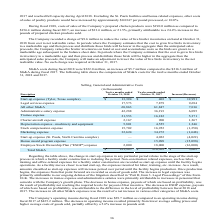From Sanderson Farms's financial document, What is the legal service expenses for fiscal years 2018 and 2017 respectively? The document shows two values: 17,573 and 7,879 (in thousands). From the document: "Legal services expense 17,573 7,879 9,694 Legal services expense 17,573 7,879 9,694..." Also, What is the Administrative salary expense for fiscal years 2018 and 2017 respectively? The document shows two values: 42,288 and 36,193 (in thousands). From the document: "Administrative salary expense 42,288 36,193 6,095 Administrative salary expense 42,288 36,193 6,095..." Also, What does the table show? the components of SG&A costs for the twelve months ended October 31, 2018 and 2017. The document states: "G&A during fiscal 2017. The following table shows the components of SG&A costs for the twelve months ended October 31, 2018 and 2017...." Also, can you calculate: What is the average Charter aircraft expense for fiscal years 2018 and 2017? To answer this question, I need to perform calculations using the financial data. The calculation is: (2,167+ 900)/2, which equals 1533.5 (in thousands). This is based on the information: "Charter aircraft expense 2,167 900 1,267 Charter aircraft expense 2,167 900 1,267..." The key data points involved are: 2,167, 900. Also, can you calculate: What is the average Employee Stock Ownership Plan ("ESOP") expense for fiscal years 2018 and 2017? To answer this question, I need to perform calculations using the financial data. The calculation is: (2,000+18,000)/2, which equals 10000 (in thousands). This is based on the information: "Employee Stock Ownership Plan ("ESOP") expense 2,000 18,000 (16,000) loyee Stock Ownership Plan ("ESOP") expense 2,000 18,000 (16,000)..." The key data points involved are: 18,000, 2,000. Also, can you calculate: What is the average Marketing expense for fiscal years 2018 and 2017? To answer this question, I need to perform calculations using the financial data. The calculation is: (32,624+ 34,272)/2, which equals 33448 (in thousands). This is based on the information: "Marketing expense 32,624 34,272 (1,648) Marketing expense 32,624 34,272 (1,648)..." The key data points involved are: 32,624, 34,272. 